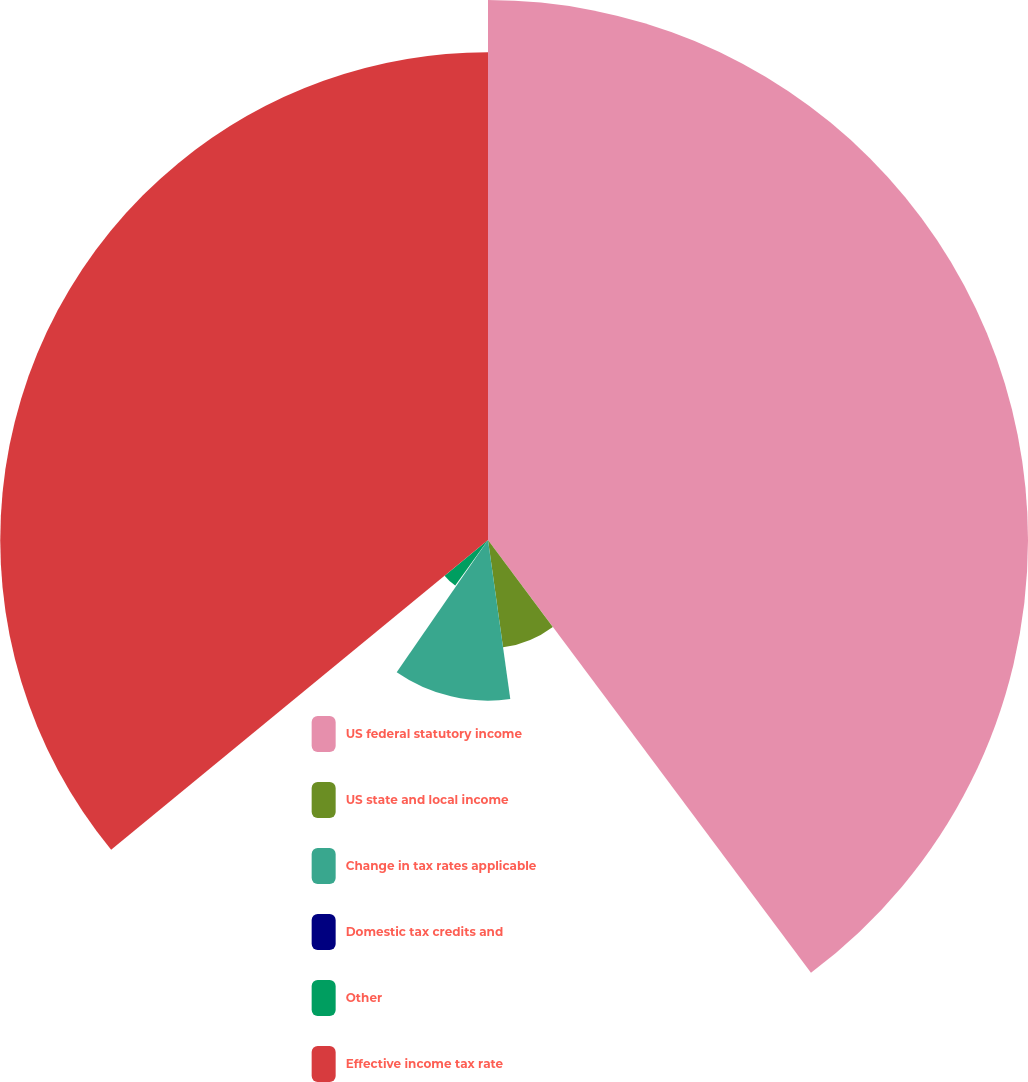<chart> <loc_0><loc_0><loc_500><loc_500><pie_chart><fcel>US federal statutory income<fcel>US state and local income<fcel>Change in tax rates applicable<fcel>Domestic tax credits and<fcel>Other<fcel>Effective income tax rate<nl><fcel>39.8%<fcel>7.99%<fcel>11.84%<fcel>0.29%<fcel>4.14%<fcel>35.95%<nl></chart> 